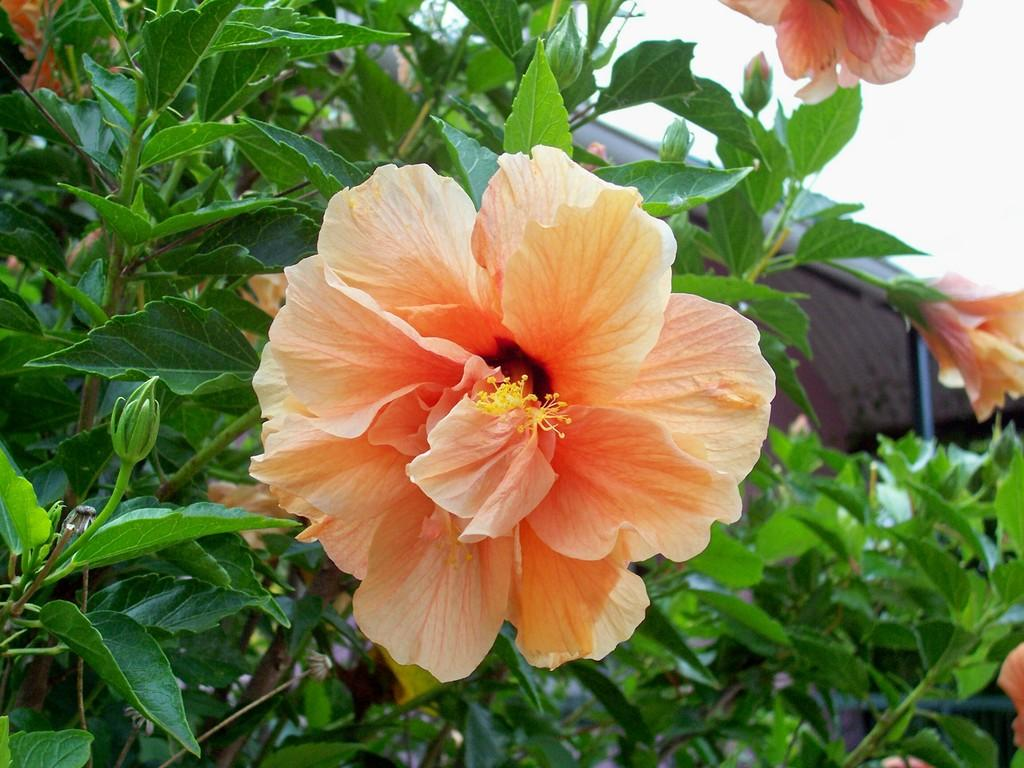What type of living organisms can be seen in the image? Plants can be seen in the image. What are the plants producing? There are flowers on the plants. What type of furniture is visible in the image? There is no furniture present in the image; it features plants with flowers. What kind of drum can be seen in the image? There is no drum present in the image; it features plants with flowers. 